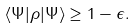Convert formula to latex. <formula><loc_0><loc_0><loc_500><loc_500>\langle \Psi | \rho | \Psi \rangle \geq 1 - \epsilon .</formula> 